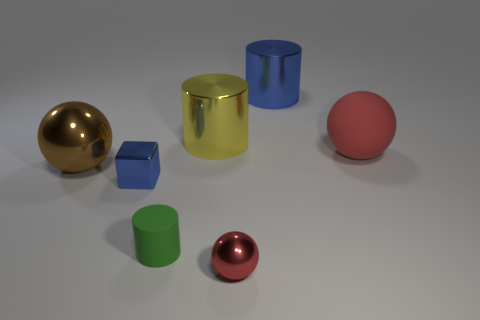What is the thing that is both behind the tiny green object and in front of the brown shiny ball made of?
Your answer should be compact. Metal. Is the number of tiny cyan rubber blocks greater than the number of big red spheres?
Give a very brief answer. No. What color is the metallic ball on the left side of the blue object that is in front of the red sphere that is on the right side of the tiny shiny sphere?
Offer a very short reply. Brown. Does the small thing in front of the small green cylinder have the same material as the big yellow thing?
Give a very brief answer. Yes. Is there a metallic thing of the same color as the tiny rubber thing?
Ensure brevity in your answer.  No. Are there any gray cylinders?
Give a very brief answer. No. There is a matte object that is behind the green matte cylinder; is its size the same as the small green object?
Give a very brief answer. No. Is the number of cyan metal things less than the number of big yellow metal objects?
Give a very brief answer. Yes. What is the shape of the red object that is in front of the blue metallic thing in front of the red sphere that is behind the big brown shiny sphere?
Provide a succinct answer. Sphere. Are there any brown cylinders that have the same material as the large blue cylinder?
Your response must be concise. No. 